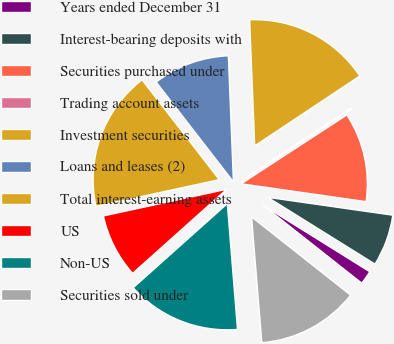<chart> <loc_0><loc_0><loc_500><loc_500><pie_chart><fcel>Years ended December 31<fcel>Interest-bearing deposits with<fcel>Securities purchased under<fcel>Trading account assets<fcel>Investment securities<fcel>Loans and leases (2)<fcel>Total interest-earning assets<fcel>US<fcel>Non-US<fcel>Securities sold under<nl><fcel>1.77%<fcel>6.61%<fcel>11.45%<fcel>0.15%<fcel>16.3%<fcel>9.84%<fcel>17.91%<fcel>8.22%<fcel>14.68%<fcel>13.07%<nl></chart> 